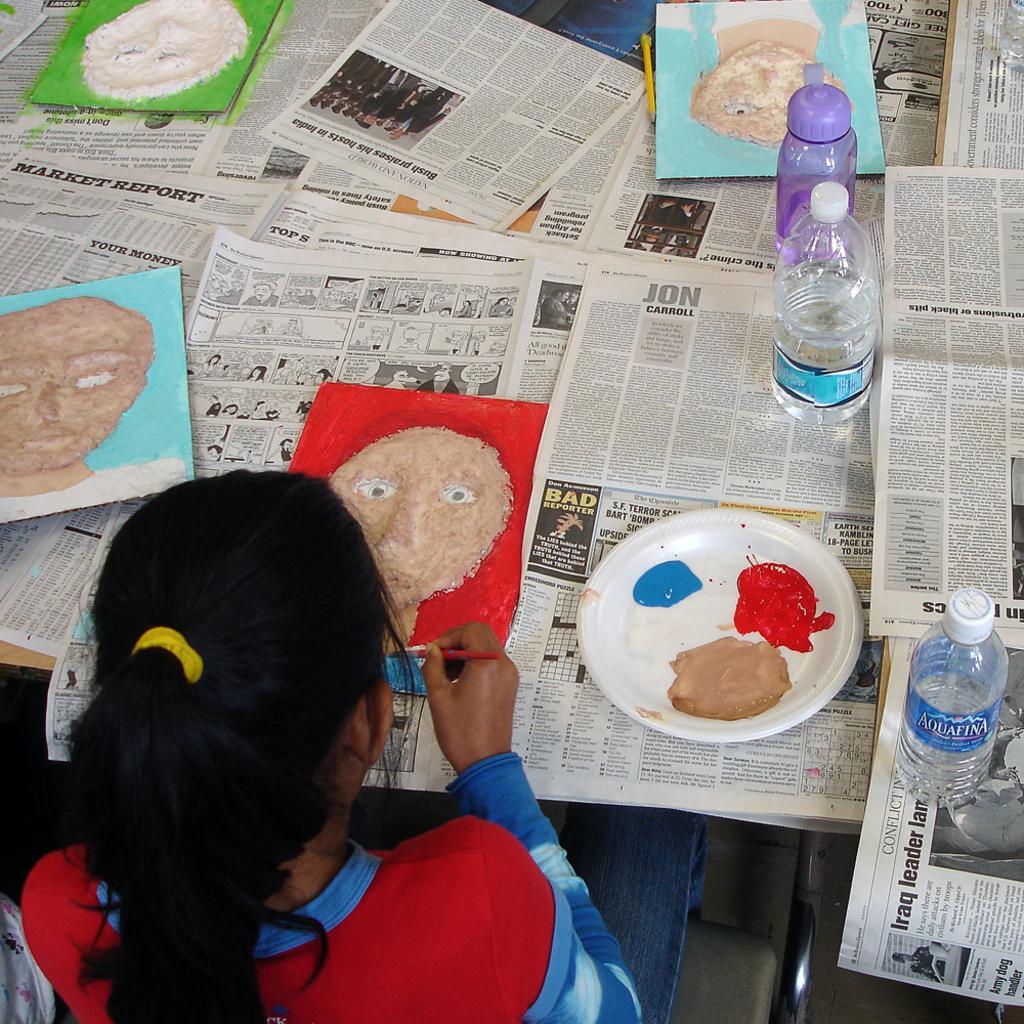In one or two sentences, can you explain what this image depicts? In this picture there is a girl sitting and painting, there are water bottles and a plate of colors provided and also there are many paintings kept on the table. 